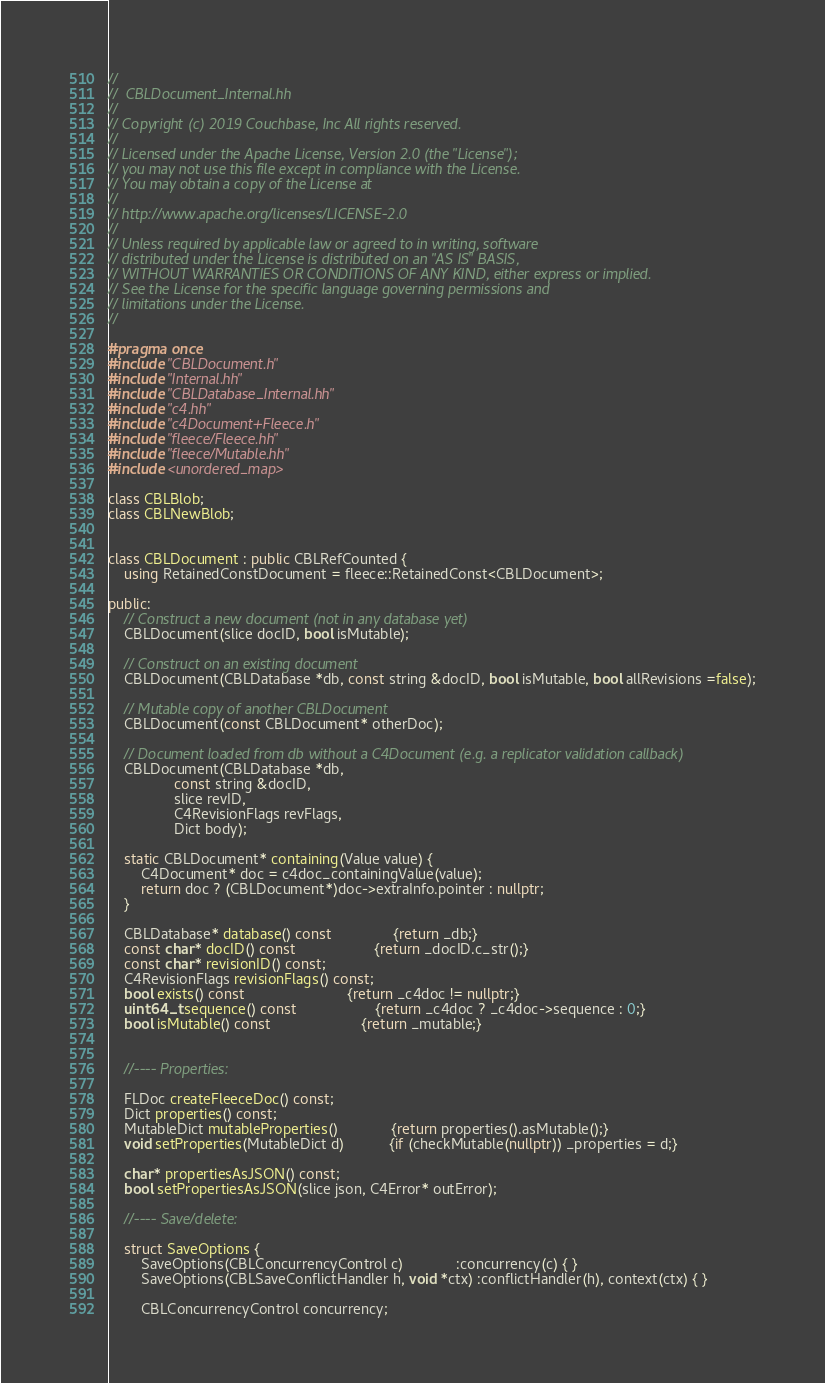Convert code to text. <code><loc_0><loc_0><loc_500><loc_500><_C++_>//
//  CBLDocument_Internal.hh
//
// Copyright (c) 2019 Couchbase, Inc All rights reserved.
//
// Licensed under the Apache License, Version 2.0 (the "License");
// you may not use this file except in compliance with the License.
// You may obtain a copy of the License at
//
// http://www.apache.org/licenses/LICENSE-2.0
//
// Unless required by applicable law or agreed to in writing, software
// distributed under the License is distributed on an "AS IS" BASIS,
// WITHOUT WARRANTIES OR CONDITIONS OF ANY KIND, either express or implied.
// See the License for the specific language governing permissions and
// limitations under the License.
//

#pragma once
#include "CBLDocument.h"
#include "Internal.hh"
#include "CBLDatabase_Internal.hh"
#include "c4.hh"
#include "c4Document+Fleece.h"
#include "fleece/Fleece.hh"
#include "fleece/Mutable.hh"
#include <unordered_map>

class CBLBlob;
class CBLNewBlob;


class CBLDocument : public CBLRefCounted {
    using RetainedConstDocument = fleece::RetainedConst<CBLDocument>;

public:
    // Construct a new document (not in any database yet)
    CBLDocument(slice docID, bool isMutable);

    // Construct on an existing document
    CBLDocument(CBLDatabase *db, const string &docID, bool isMutable, bool allRevisions =false);

    // Mutable copy of another CBLDocument
    CBLDocument(const CBLDocument* otherDoc);

    // Document loaded from db without a C4Document (e.g. a replicator validation callback)
    CBLDocument(CBLDatabase *db,
                const string &docID,
                slice revID,
                C4RevisionFlags revFlags,
                Dict body);

    static CBLDocument* containing(Value value) {
        C4Document* doc = c4doc_containingValue(value);
        return doc ? (CBLDocument*)doc->extraInfo.pointer : nullptr;
    }

    CBLDatabase* database() const               {return _db;}
    const char* docID() const                   {return _docID.c_str();}
    const char* revisionID() const;
    C4RevisionFlags revisionFlags() const;
    bool exists() const                         {return _c4doc != nullptr;}
    uint64_t sequence() const                   {return _c4doc ? _c4doc->sequence : 0;}
    bool isMutable() const                      {return _mutable;}


    //---- Properties:

    FLDoc createFleeceDoc() const;
    Dict properties() const;
    MutableDict mutableProperties()             {return properties().asMutable();}
    void setProperties(MutableDict d)           {if (checkMutable(nullptr)) _properties = d;}

    char* propertiesAsJSON() const;
    bool setPropertiesAsJSON(slice json, C4Error* outError);

    //---- Save/delete:

    struct SaveOptions {
        SaveOptions(CBLConcurrencyControl c)             :concurrency(c) { }
        SaveOptions(CBLSaveConflictHandler h, void *ctx) :conflictHandler(h), context(ctx) { }

        CBLConcurrencyControl concurrency;</code> 